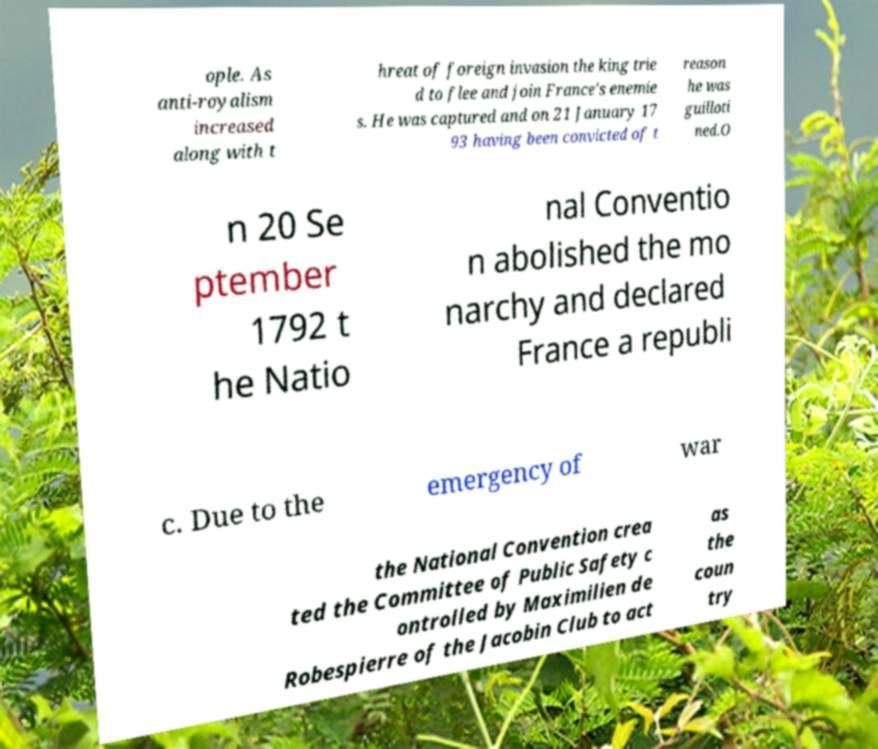Can you read and provide the text displayed in the image?This photo seems to have some interesting text. Can you extract and type it out for me? ople. As anti-royalism increased along with t hreat of foreign invasion the king trie d to flee and join France's enemie s. He was captured and on 21 January 17 93 having been convicted of t reason he was guilloti ned.O n 20 Se ptember 1792 t he Natio nal Conventio n abolished the mo narchy and declared France a republi c. Due to the emergency of war the National Convention crea ted the Committee of Public Safety c ontrolled by Maximilien de Robespierre of the Jacobin Club to act as the coun try 